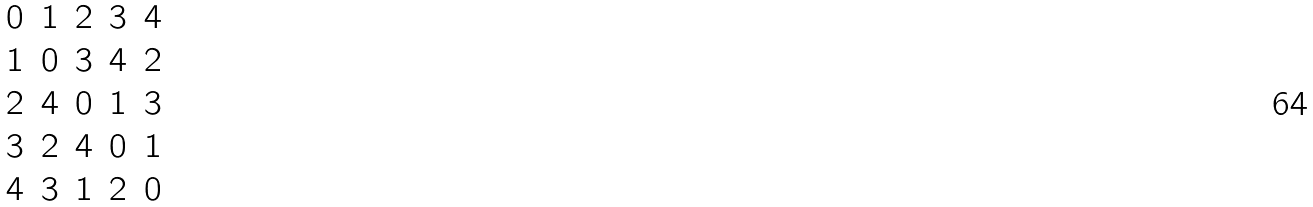<formula> <loc_0><loc_0><loc_500><loc_500>\begin{array} { c c c c c } 0 & 1 & 2 & 3 & 4 \\ 1 & 0 & 3 & 4 & 2 \\ 2 & 4 & 0 & 1 & 3 \\ 3 & 2 & 4 & 0 & 1 \\ 4 & 3 & 1 & 2 & 0 \end{array}</formula> 